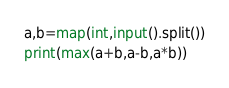Convert code to text. <code><loc_0><loc_0><loc_500><loc_500><_Python_>a,b=map(int,input().split())
print(max(a+b,a-b,a*b))</code> 